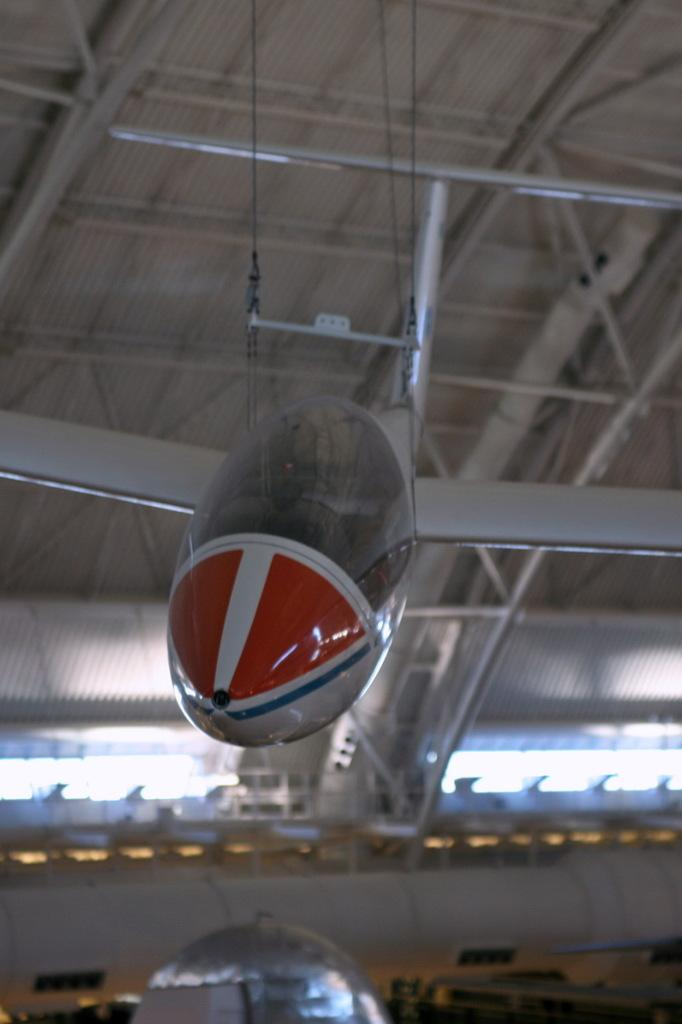What is the main subject of the image? The main subject of the image is an aircraft. Can you describe any other objects present in the image? Yes, there are some objects in the image. What can be seen in the background of the image? There is a roof visible in the background of the image. What type of yoke is the aircraft using in the image? The image does not provide information about the type of yoke the aircraft is using. Is the aircraft being used for spying purposes in the image? The image does not provide any information about the purpose of the aircraft. Can you tell me if there is a carpenter working on the roof in the image? The image does not show any carpenters or any roof work being done. 